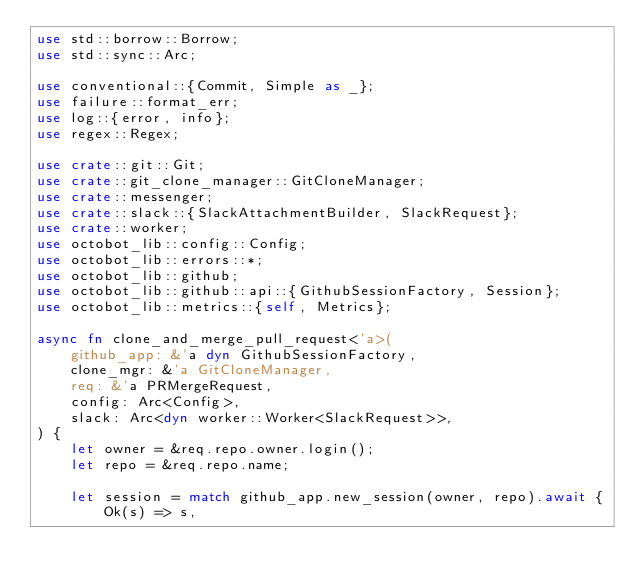Convert code to text. <code><loc_0><loc_0><loc_500><loc_500><_Rust_>use std::borrow::Borrow;
use std::sync::Arc;

use conventional::{Commit, Simple as _};
use failure::format_err;
use log::{error, info};
use regex::Regex;

use crate::git::Git;
use crate::git_clone_manager::GitCloneManager;
use crate::messenger;
use crate::slack::{SlackAttachmentBuilder, SlackRequest};
use crate::worker;
use octobot_lib::config::Config;
use octobot_lib::errors::*;
use octobot_lib::github;
use octobot_lib::github::api::{GithubSessionFactory, Session};
use octobot_lib::metrics::{self, Metrics};

async fn clone_and_merge_pull_request<'a>(
    github_app: &'a dyn GithubSessionFactory,
    clone_mgr: &'a GitCloneManager,
    req: &'a PRMergeRequest,
    config: Arc<Config>,
    slack: Arc<dyn worker::Worker<SlackRequest>>,
) {
    let owner = &req.repo.owner.login();
    let repo = &req.repo.name;

    let session = match github_app.new_session(owner, repo).await {
        Ok(s) => s,</code> 